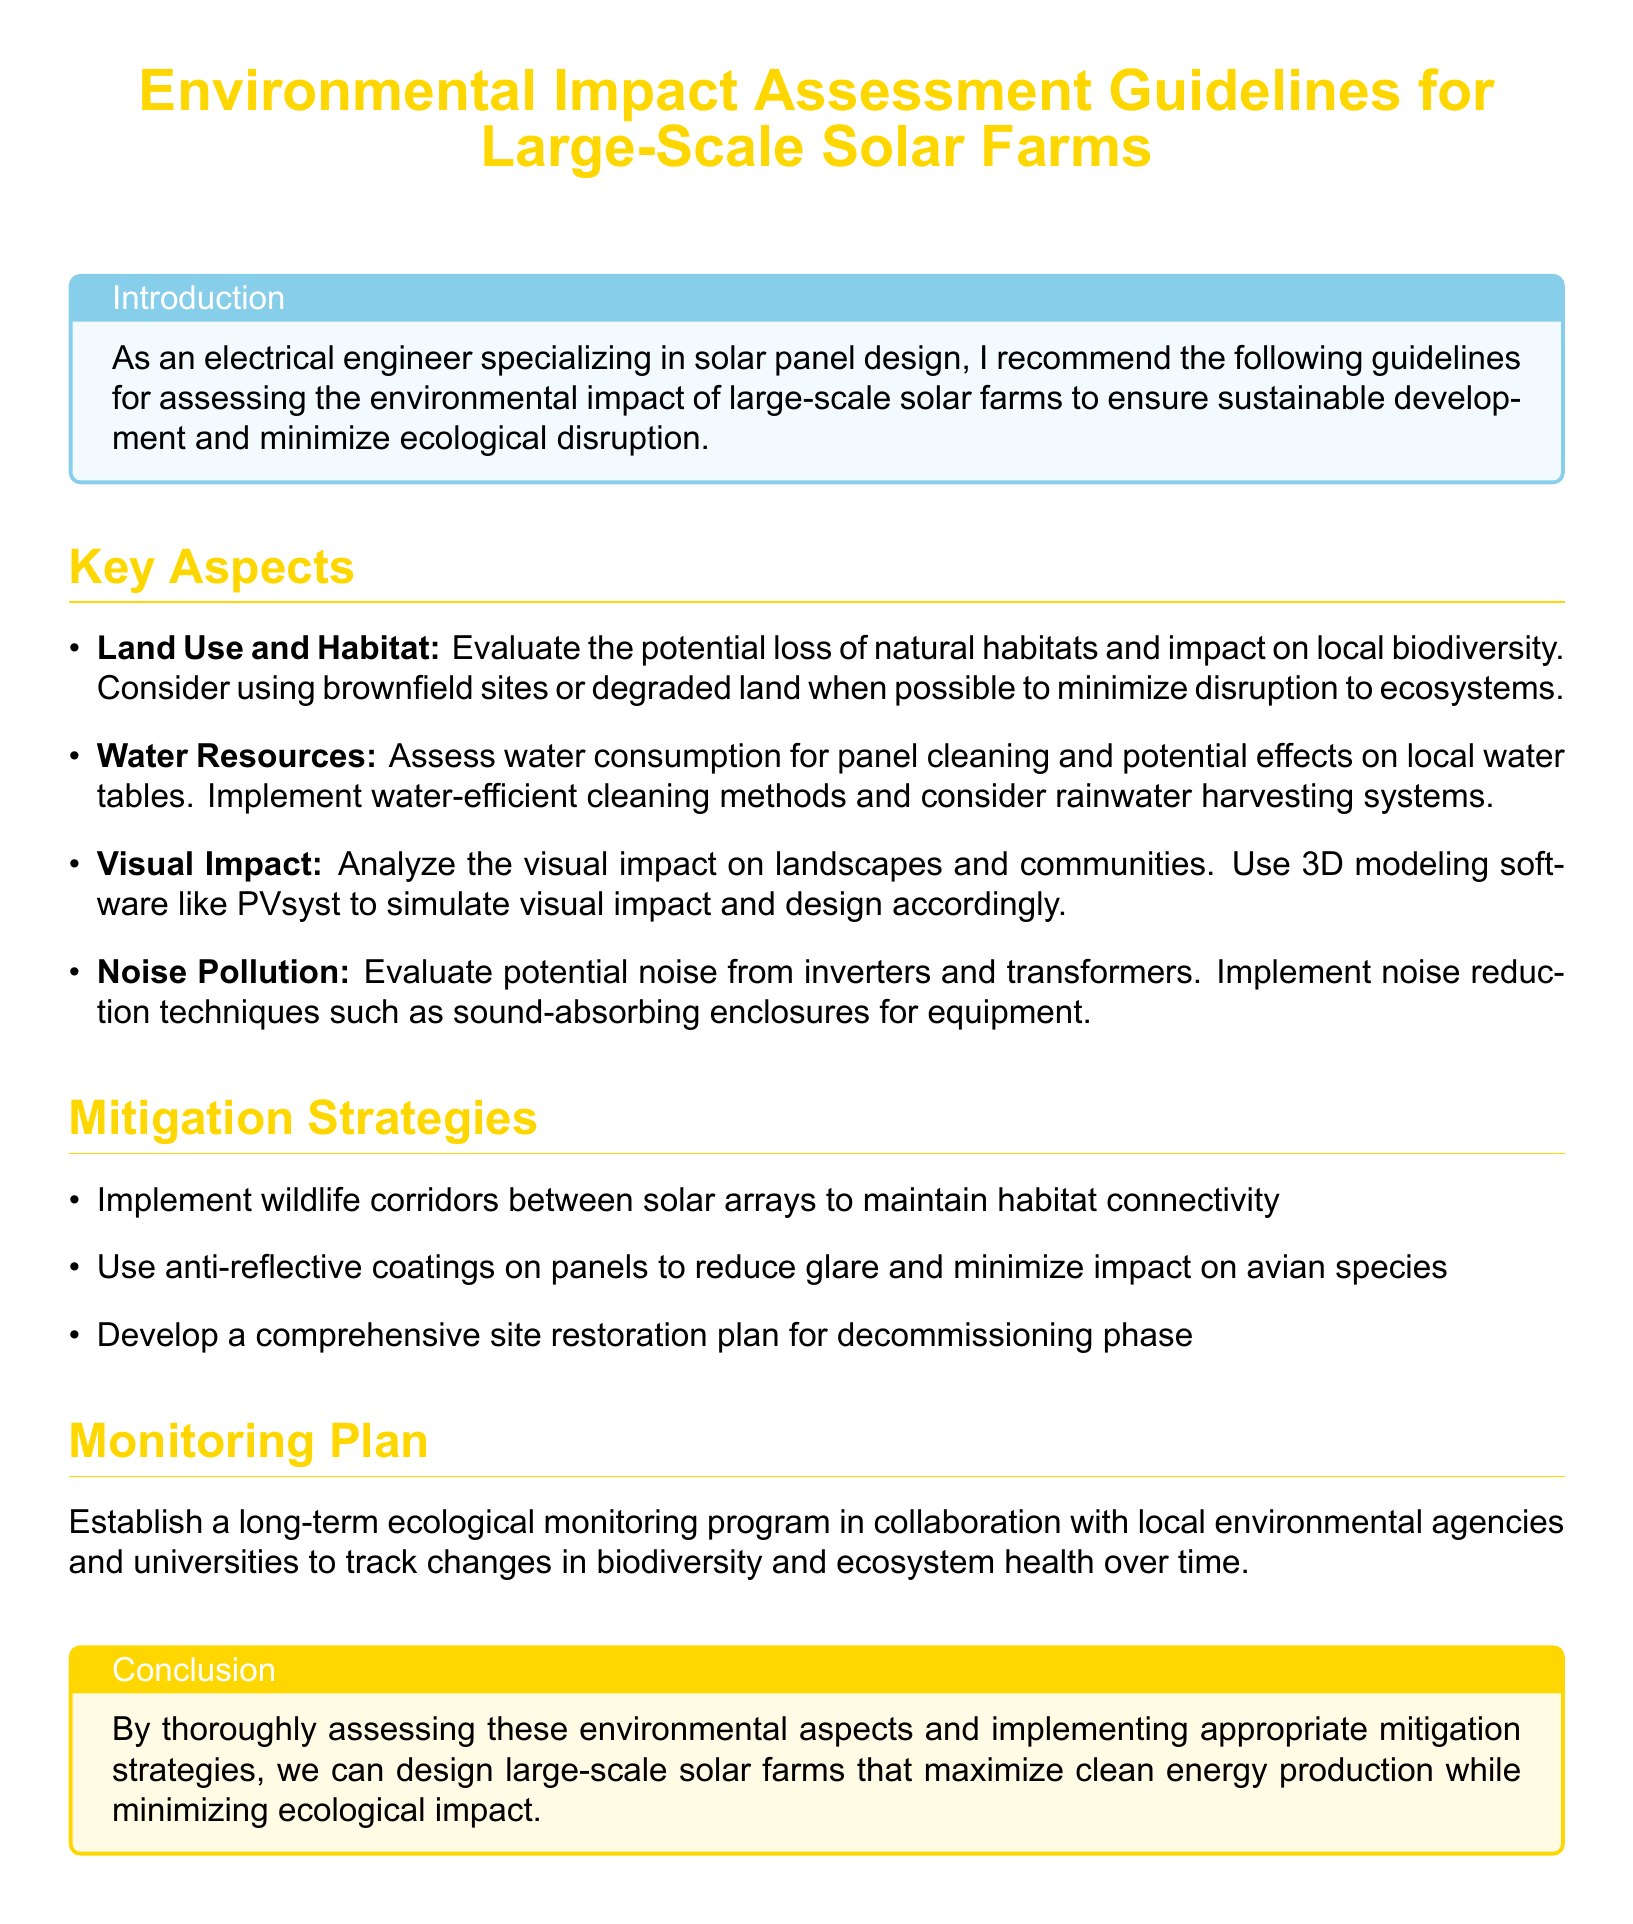What is the title of the document? The title of the document is the main heading provided at the beginning, indicating the subject of the guidelines.
Answer: Environmental Impact Assessment Guidelines for Large-Scale Solar Farms What color is used for the introduction box? The introduction box has a specific background color that enhances its visibility.
Answer: Sky blue What is one recommended method to assess visual impact? The document suggests using a particular software to simulate the visual effects of solar farms on landscapes.
Answer: 3D modeling software What should be implemented to maintain habitat connectivity? The guidelines recommend a specific strategy that enhances the ecological flow between areas.
Answer: Wildlife corridors Which component has potential noise that needs evaluation? The document identifies a particular piece of equipment that may generate noise pollution.
Answer: Inverters and transformers What is one strategy for reducing glare on panels? The document mentions a specific type of coating that can be applied to panels to minimize glare effects.
Answer: Anti-reflective coatings What type of monitoring program should be established? The document advises setting up a specific type of monitoring program involving collaboration with local entities.
Answer: Long-term ecological monitoring program What does the conclusion emphasize? The conclusion summarizes the primary goal of conducting thorough assessments and implementing strategies.
Answer: Maximizing clean energy production while minimizing ecological impact 